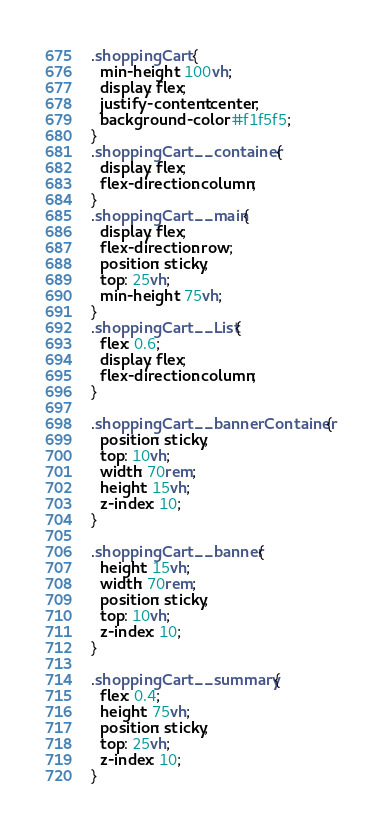Convert code to text. <code><loc_0><loc_0><loc_500><loc_500><_CSS_>.shoppingCart {
  min-height: 100vh;
  display: flex;
  justify-content: center;
  background-color: #f1f5f5;
}
.shoppingCart__container {
  display: flex;
  flex-direction: column;
}
.shoppingCart__main {
  display: flex;
  flex-direction: row;
  position: sticky;
  top: 25vh;
  min-height: 75vh;
}
.shoppingCart__List {
  flex: 0.6;
  display: flex;
  flex-direction: column;
}

.shoppingCart__bannerContainer {
  position: sticky;
  top: 10vh;
  width: 70rem;
  height: 15vh;
  z-index: 10;
}

.shoppingCart__banner {
  height: 15vh;
  width: 70rem;
  position: sticky;
  top: 10vh;
  z-index: 10;
}

.shoppingCart__summary {
  flex: 0.4;
  height: 75vh;
  position: sticky;
  top: 25vh;
  z-index: 10;
}
</code> 